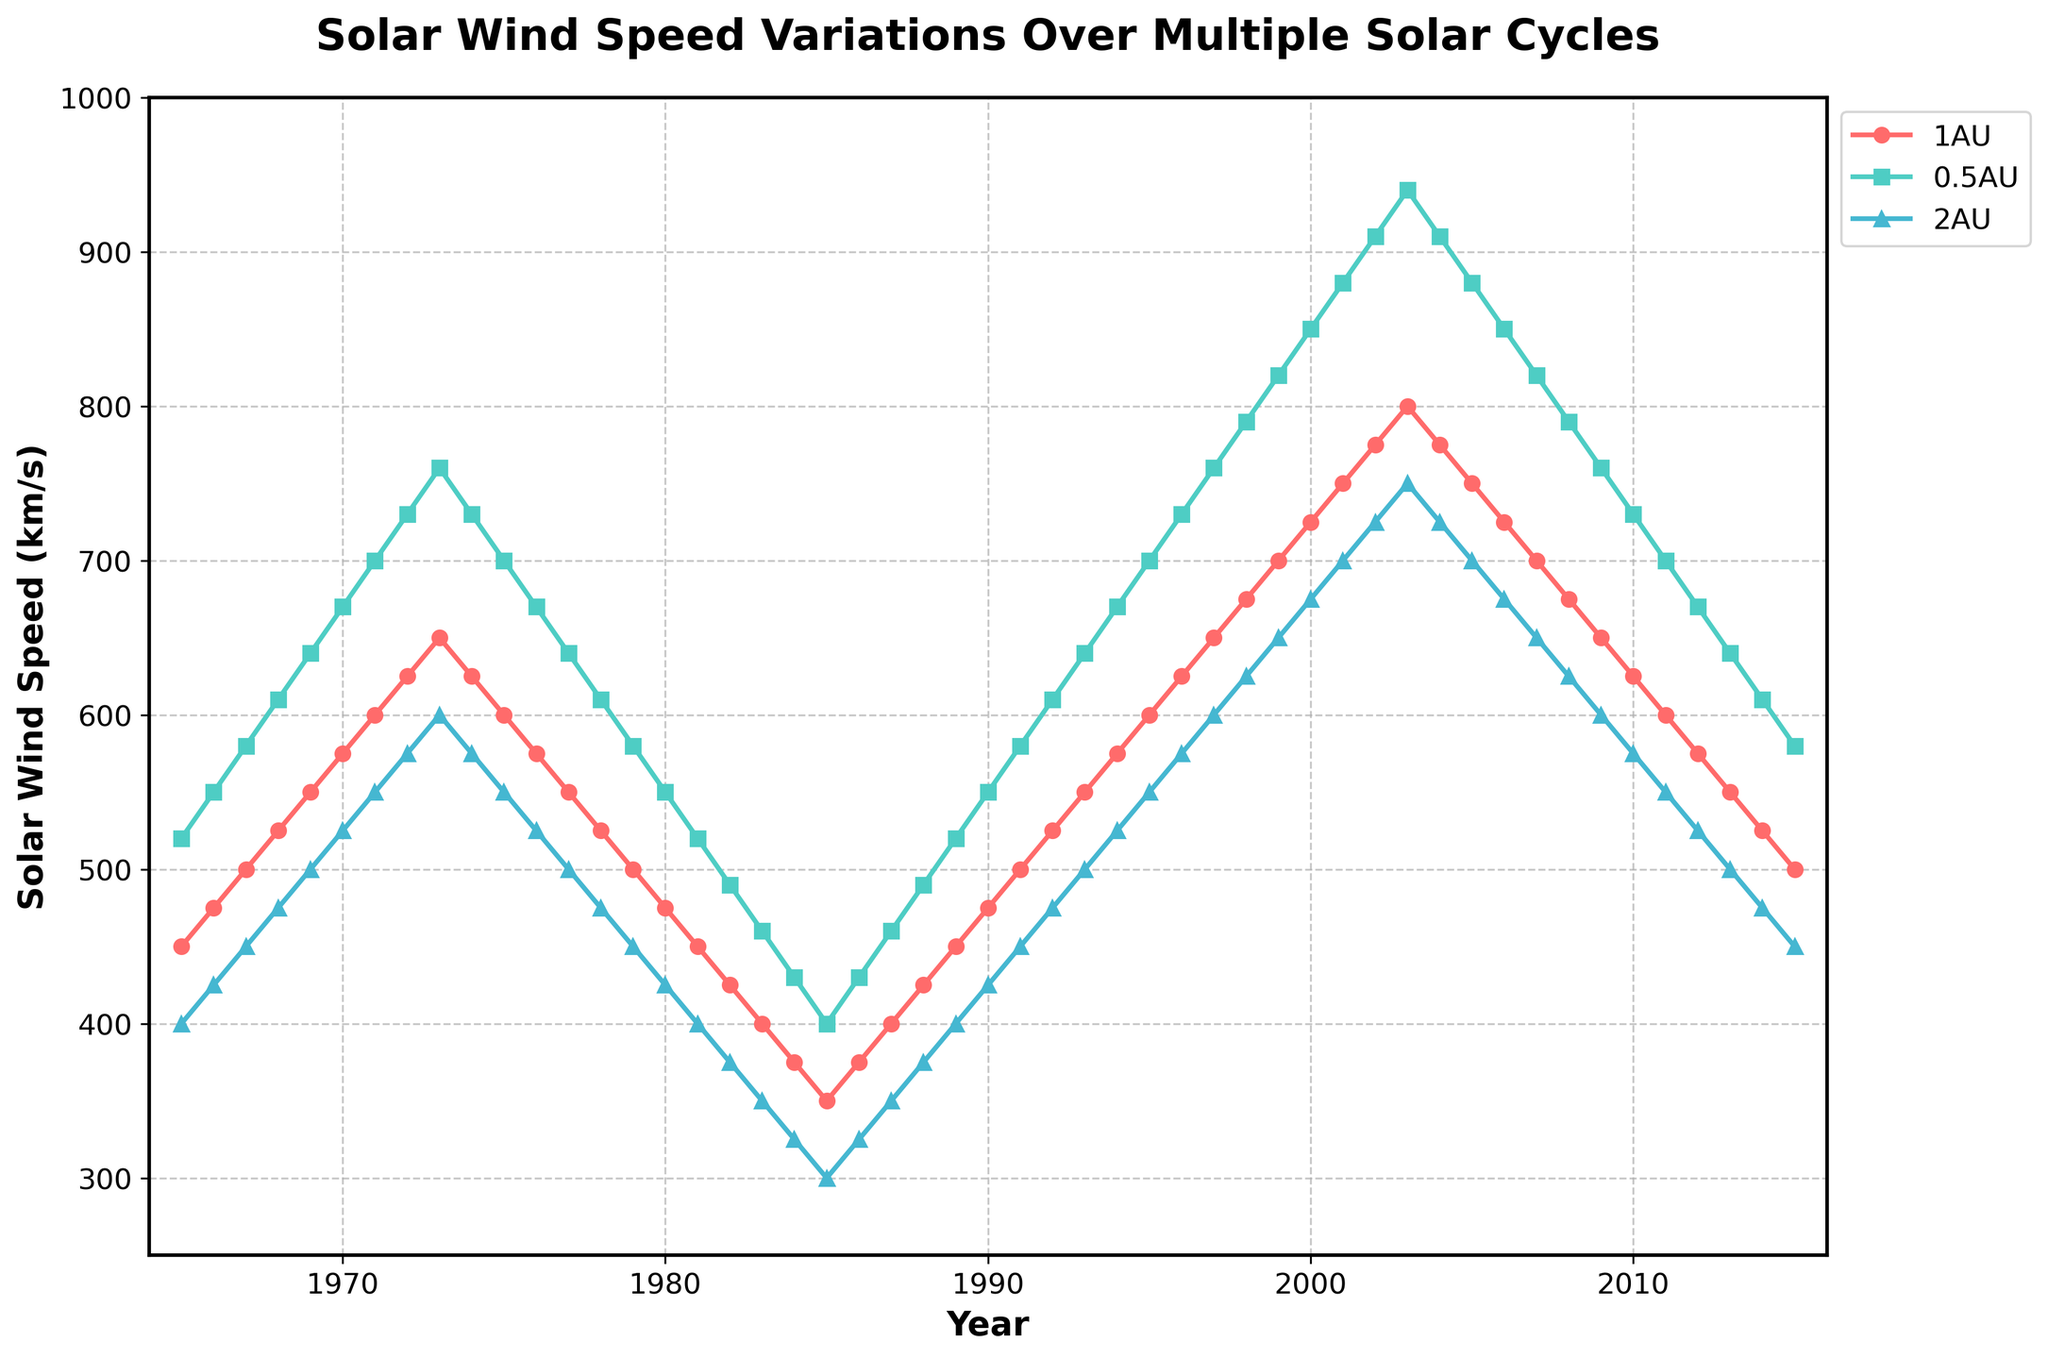What's the trend in solar wind speed at 1AU from 1965 to 2015? From the visual plot, the solar wind speed at 1 AU shows an oscillatory behavior with cycles of increase and decrease, reflecting the solar cycles. Over long periods, the speed varies significantly between 350 km/s and 800 km/s, peaking in early 2000s.
Answer: Oscillatory trend with peaks around early 2000s Which distance had the highest solar wind speed in 2003? Looking at the plotted lines, in 2003, the line for 0.5AU is the highest, showing that the solar wind speed is maximum at 0.5AU compared to the other distances.
Answer: 0.5AU In what year was the solar wind speed the same at 1AU and 2AU? By comparing the lines, the speeds at 1AU and 2AU converge around the year 1974 where both lines intersect at around the same point on the vertical axis.
Answer: 1974 What is the average solar wind speed at 1AU in the years 1970, 1980, and 1990? The speeds at 1AU for these years are 575 km/s, 475 km/s, and 475 km/s respectively. The average is calculated as (575 + 475 + 475) / 3.
Answer: 508.33 km/s At which heliocentric distance does the solar wind speed show the greatest variation over the study period? By inspecting the amplitude of the oscillations, 0.5AU shows the largest range from approximately 300 km/s to 940 km/s compared to 1AU and 2AU.
Answer: 0.5AU Compare the solar wind speeds at 2AU in 1966 and 2010. Which year showed higher speed and by how much? The speed at 2AU in 1966 is 425 km/s and in 2010, it is 575 km/s. The difference is 575 - 425.
Answer: 2010, by 150 km/s In which year did the solar wind speed at 0.5AU reach its maximum, and what was the value? The maximum speed at 0.5AU is the highest point on the line corresponding to 0.5AU which occurs in 2003 at 940 km/s.
Answer: 2003, 940 km/s How does the solar wind speed at 0.5AU in 1986 compare to that at 1AU in 1986? Comparing the values for 1986 from the respective lines, the speed at 0.5AU is 430 km/s and at 1AU is 375 km/s, showing the speed is higher at 0.5AU.
Answer: Higher at 0.5AU What is the difference in solar wind speed at 2AU between its peak value in 2003 and its lowest value in 1985? The peak speed at 2AU in 2003 is 750 km/s and the lowest in 1985 is 300 km/s. The difference is 750 - 300.
Answer: 450 km/s During which solar cycle did the average solar wind speed at 1AU remain largely constant? Over the solar cycles, the period from around 1980 to 1990 appears relatively flat based on the figure, signifying less fluctuation in the solar wind speeds.
Answer: 1980-1990 